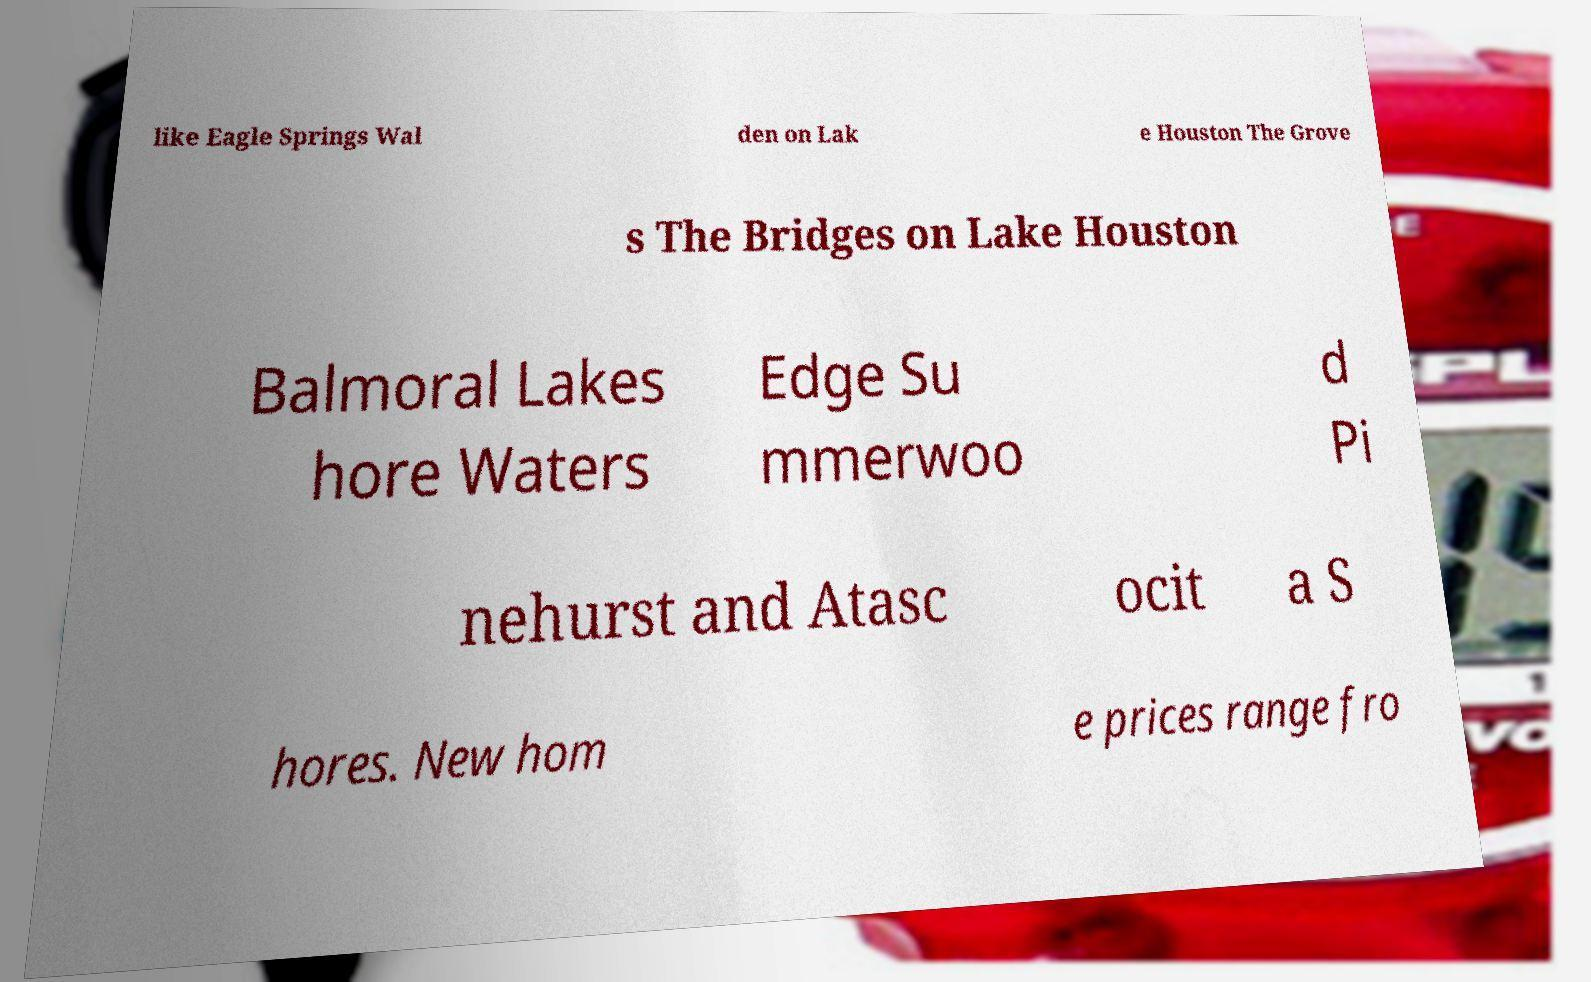Could you extract and type out the text from this image? like Eagle Springs Wal den on Lak e Houston The Grove s The Bridges on Lake Houston Balmoral Lakes hore Waters Edge Su mmerwoo d Pi nehurst and Atasc ocit a S hores. New hom e prices range fro 